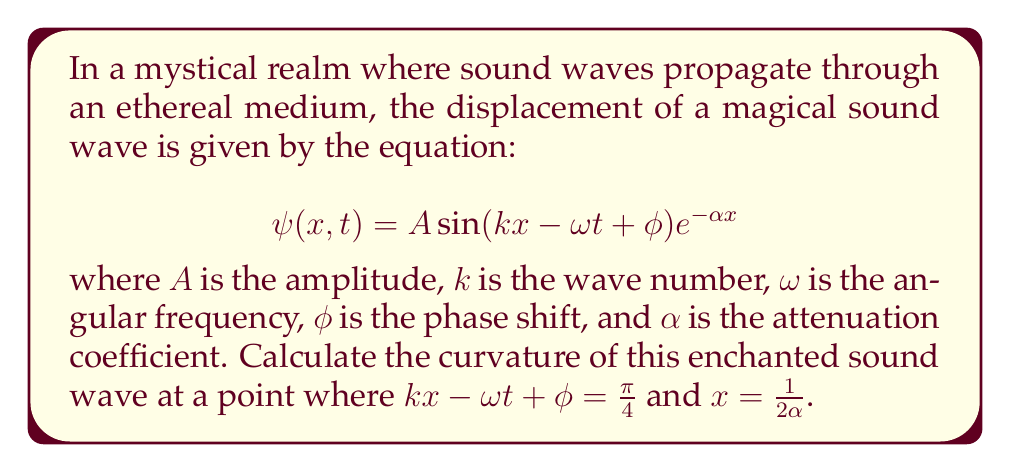Can you solve this math problem? To calculate the curvature of the sound wave, we'll follow these mystical steps:

1) The curvature of a wave is given by the formula:

   $$\kappa = \frac{|\frac{\partial^2 \psi}{\partial x^2}|}{[1 + (\frac{\partial \psi}{\partial x})^2]^{3/2}}$$

2) First, let's calculate $\frac{\partial \psi}{\partial x}$:
   
   $$\frac{\partial \psi}{\partial x} = A(k\cos(kx - \omega t + \phi) - \alpha \sin(kx - \omega t + \phi))e^{-\alpha x}$$

3) Now, let's calculate $\frac{\partial^2 \psi}{\partial x^2}$:
   
   $$\frac{\partial^2 \psi}{\partial x^2} = A(-k^2\sin(kx - \omega t + \phi) - 2\alpha k\cos(kx - \omega t + \phi) + \alpha^2 \sin(kx - \omega t + \phi))e^{-\alpha x}$$

4) At the given point, $kx - \omega t + \phi = \frac{\pi}{4}$ and $x = \frac{1}{2\alpha}$. Let's substitute these values:

   $$\frac{\partial \psi}{\partial x} = A(k\cos(\frac{\pi}{4}) - \alpha \sin(\frac{\pi}{4}))e^{-1/2}$$
   
   $$\frac{\partial^2 \psi}{\partial x^2} = A(-k^2\sin(\frac{\pi}{4}) - 2\alpha k\cos(\frac{\pi}{4}) + \alpha^2 \sin(\frac{\pi}{4}))e^{-1/2}$$

5) Simplify using $\cos(\frac{\pi}{4}) = \sin(\frac{\pi}{4}) = \frac{1}{\sqrt{2}}$:

   $$\frac{\partial \psi}{\partial x} = \frac{A}{\sqrt{2}}(k - \alpha)e^{-1/2}$$
   
   $$\frac{\partial^2 \psi}{\partial x^2} = \frac{A}{\sqrt{2}}(-k^2 - 2\alpha k + \alpha^2)e^{-1/2}$$

6) Now we can calculate the curvature:

   $$\kappa = \frac{|\frac{A}{\sqrt{2}}(-k^2 - 2\alpha k + \alpha^2)e^{-1/2}|}{[1 + (\frac{A}{\sqrt{2}}(k - \alpha)e^{-1/2})^2]^{3/2}}$$

7) Simplify:

   $$\kappa = \frac{|A(-k^2 - 2\alpha k + \alpha^2)|}{[\sqrt{2}e^{1/2} + \frac{A^2}{2}(k - \alpha)^2e^{-1}]^{3/2}}$$

This is the magical curvature of the enchanted sound wave at the specified point.
Answer: $$\kappa = \frac{|A(-k^2 - 2\alpha k + \alpha^2)|}{[\sqrt{2}e^{1/2} + \frac{A^2}{2}(k - \alpha)^2e^{-1}]^{3/2}}$$ 